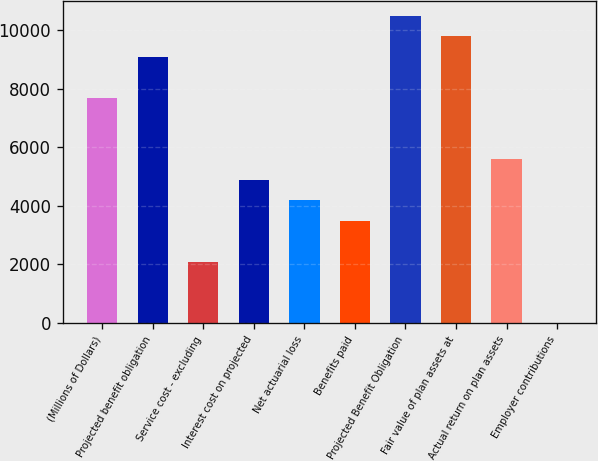Convert chart. <chart><loc_0><loc_0><loc_500><loc_500><bar_chart><fcel>(Millions of Dollars)<fcel>Projected benefit obligation<fcel>Service cost - excluding<fcel>Interest cost on projected<fcel>Net actuarial loss<fcel>Benefits paid<fcel>Projected Benefit Obligation<fcel>Fair value of plan assets at<fcel>Actual return on plan assets<fcel>Employer contributions<nl><fcel>7683.3<fcel>9079.9<fcel>2096.9<fcel>4890.1<fcel>4191.8<fcel>3493.5<fcel>10476.5<fcel>9778.2<fcel>5588.4<fcel>2<nl></chart> 